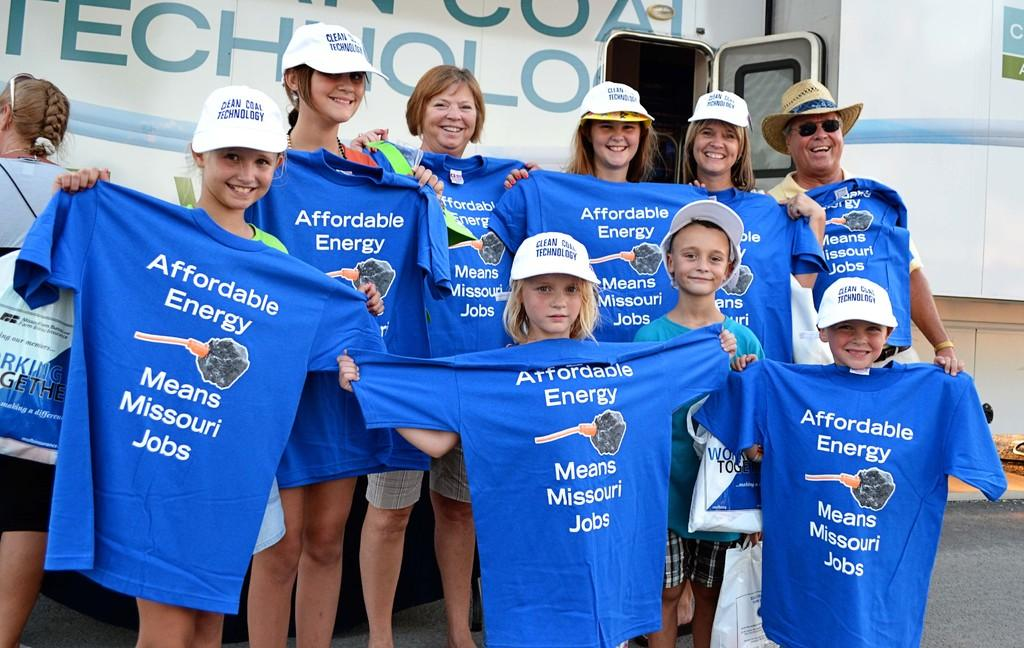<image>
Describe the image concisely. Children holding blue shirts that say Affordable Energy Means Missouri Jobs. 